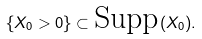Convert formula to latex. <formula><loc_0><loc_0><loc_500><loc_500>\{ X _ { 0 } > 0 \} \subset \text {Supp} ( X _ { 0 } ) .</formula> 